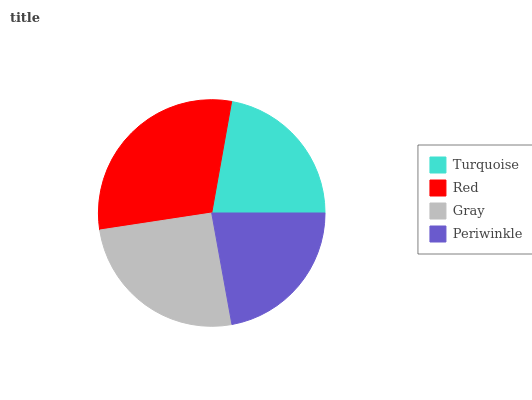Is Periwinkle the minimum?
Answer yes or no. Yes. Is Red the maximum?
Answer yes or no. Yes. Is Gray the minimum?
Answer yes or no. No. Is Gray the maximum?
Answer yes or no. No. Is Red greater than Gray?
Answer yes or no. Yes. Is Gray less than Red?
Answer yes or no. Yes. Is Gray greater than Red?
Answer yes or no. No. Is Red less than Gray?
Answer yes or no. No. Is Gray the high median?
Answer yes or no. Yes. Is Turquoise the low median?
Answer yes or no. Yes. Is Turquoise the high median?
Answer yes or no. No. Is Red the low median?
Answer yes or no. No. 